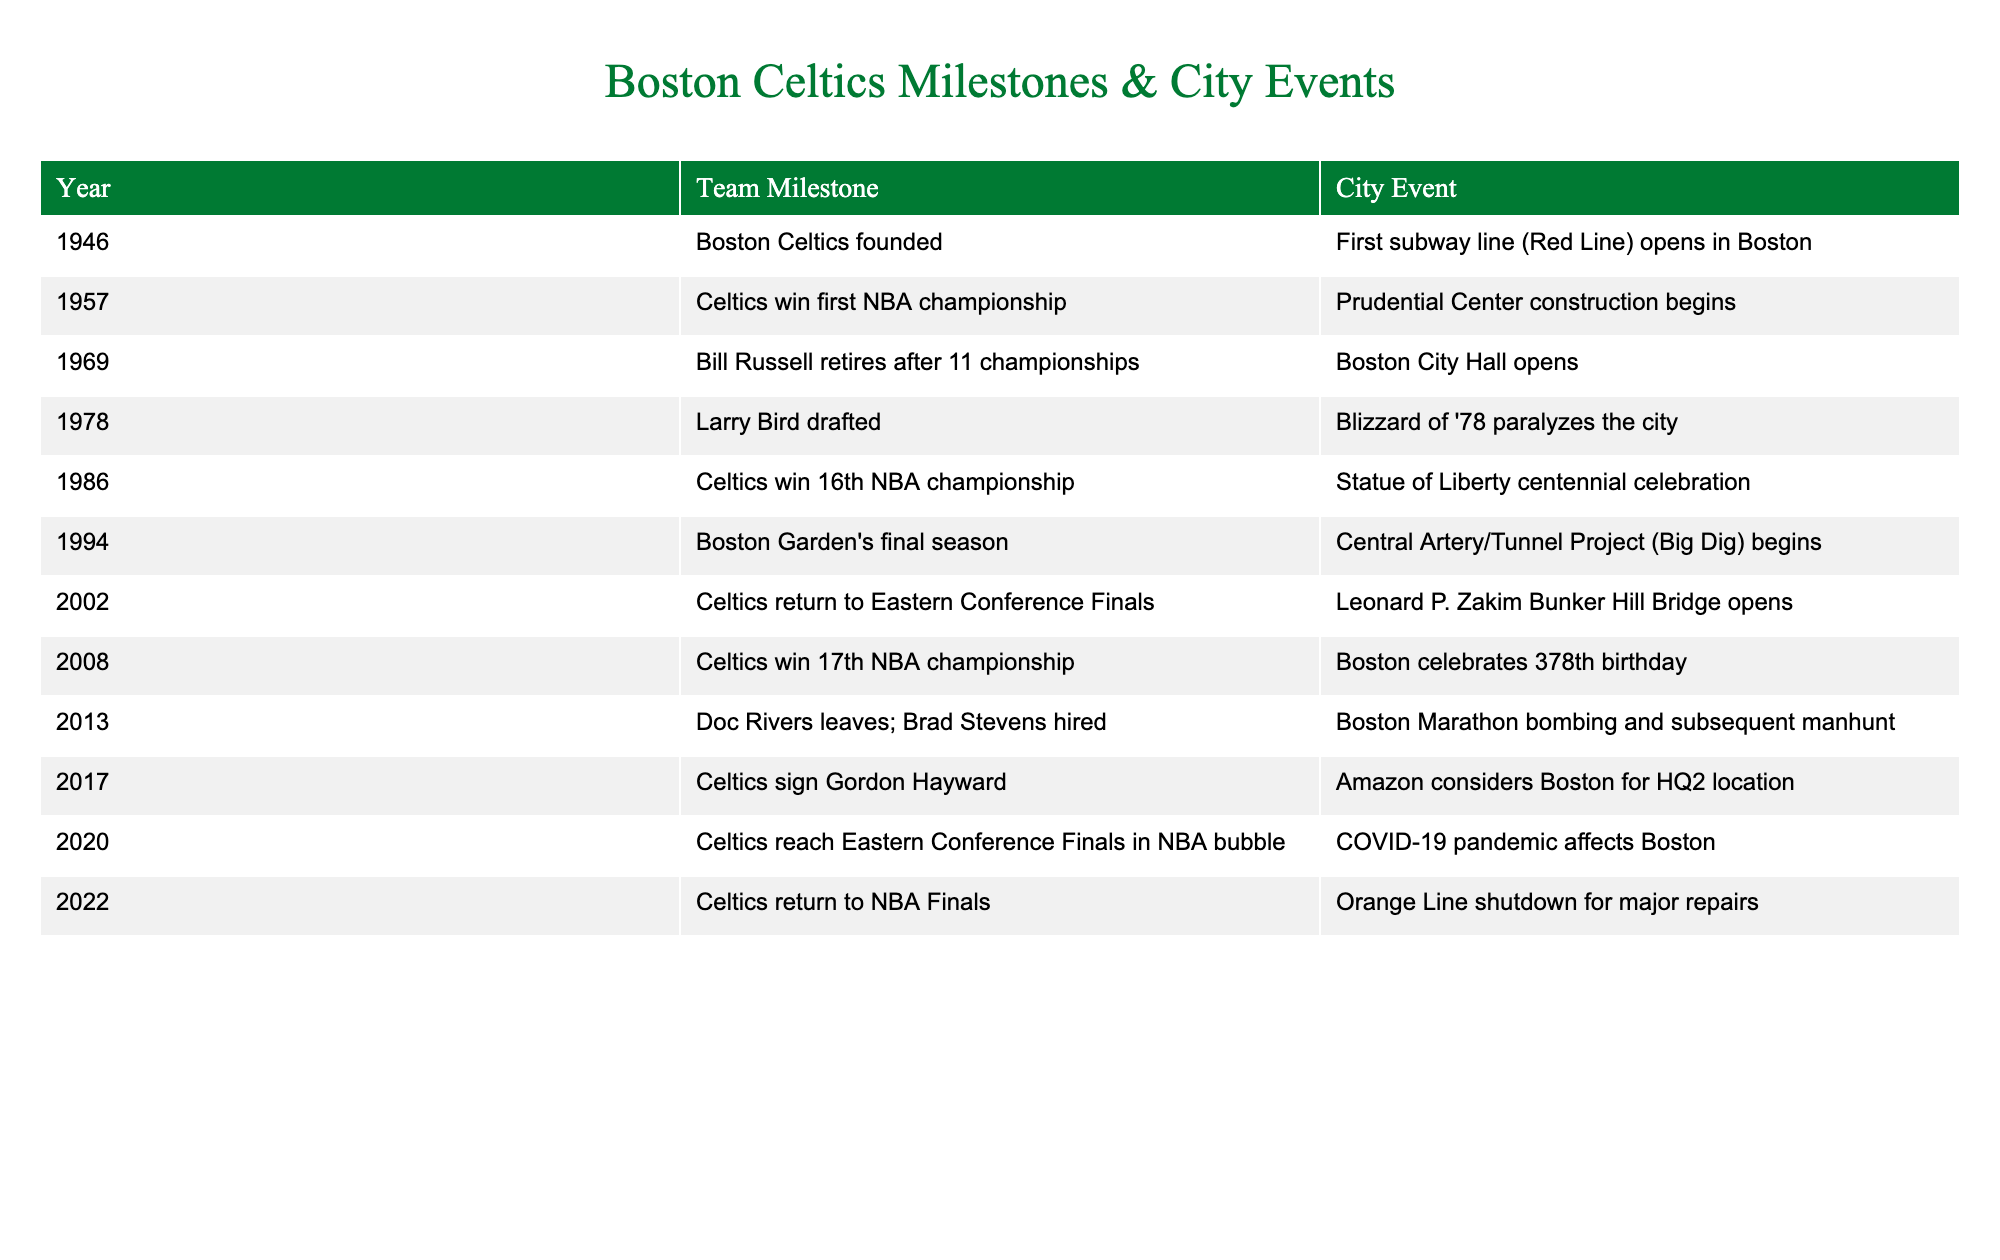What year were the Boston Celtics founded? The first row of the table indicates that the Boston Celtics were founded in 1946.
Answer: 1946 What significant city event coincided with the Celtics' first championship win? The second row shows that the Celtics won their first NBA championship in 1957, which coincided with the beginning of Prudential Center construction in Boston.
Answer: Prudential Center construction begins When did Larry Bird get drafted by the Celtics? From the table, Larry Bird was drafted in 1978, which is noted in the fourth row.
Answer: 1978 What milestone did the team achieve in 2008? The table indicates that in 2008, the Celtics won their 17th NBA championship.
Answer: Celtics win 17th NBA championship Was there a significant city event that occurred in the same year the Celtics returned to the NBA Finals? In 2022, the Celtics returned to the NBA Finals, and the corresponding city event was the Orange Line shutdown for major repairs, as seen in the last row.
Answer: Yes How many years passed between the Celtics' first NBA championship and the 17th championship win? The first championship was in 1957 and the 17th in 2008. Calculating the difference, 2008 - 1957 gives us 51 years.
Answer: 51 years Did the Celtics' success in the playoffs coincide with any major events in Boston history? Yes, several milestones and city events coincide; for example, the Celtics returned to the Eastern Conference Finals in 2002 in parallel with the opening of the Leonard P. Zakim Bunker Hill Bridge.
Answer: Yes How many championships did Bill Russell win before his retirement? The table notes that Bill Russell retired after winning 11 championships, which is stated in the row from 1969.
Answer: 11 championships What year did the Celtics reach the Eastern Conference Finals in the NBA bubble, and what was happening in Boston at that time? According to the table, the Celtics reached the Eastern Conference Finals in 2020, during the COVID-19 pandemic affecting Boston.
Answer: 2020; COVID-19 pandemic affects Boston What city event occurred after the Celtics' first championship but before Bill Russell retired? The table shows that Boston City Hall opened in 1969, which is after the Celtics' first championship win in 1957 but before Bill Russell's retirement in the same year.
Answer: Boston City Hall opens 